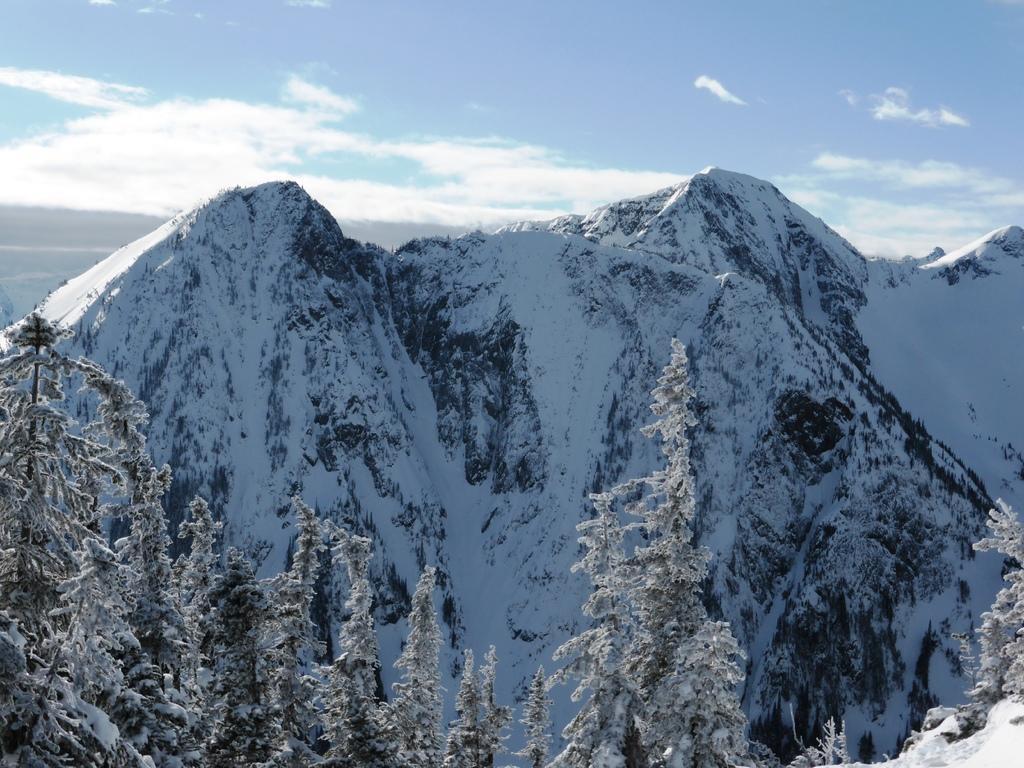In one or two sentences, can you explain what this image depicts? In the image there are trees in the front covered with snow and behind there are mountains with snow all over it and above its sky with clouds. 